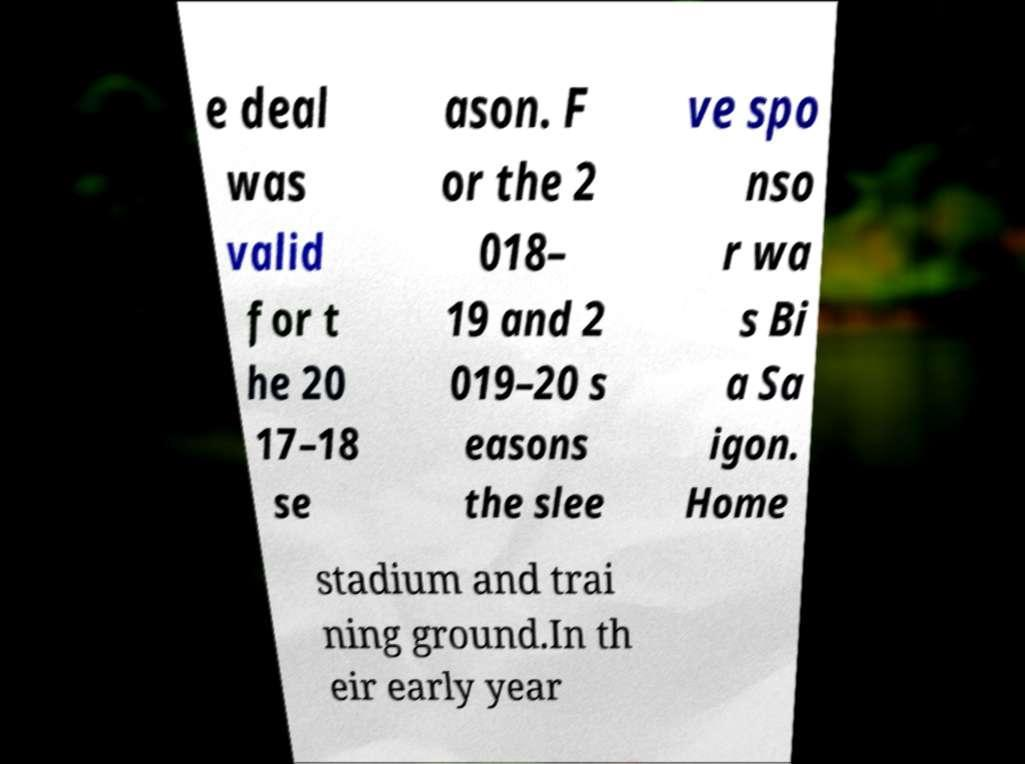Please read and relay the text visible in this image. What does it say? e deal was valid for t he 20 17–18 se ason. F or the 2 018– 19 and 2 019–20 s easons the slee ve spo nso r wa s Bi a Sa igon. Home stadium and trai ning ground.In th eir early year 